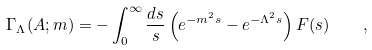Convert formula to latex. <formula><loc_0><loc_0><loc_500><loc_500>\Gamma _ { \Lambda } ( A ; m ) = - \int _ { 0 } ^ { \infty } \frac { d s } { s } \left ( e ^ { - m ^ { 2 } s } - e ^ { - \Lambda ^ { 2 } s } \right ) F ( s ) \quad ,</formula> 